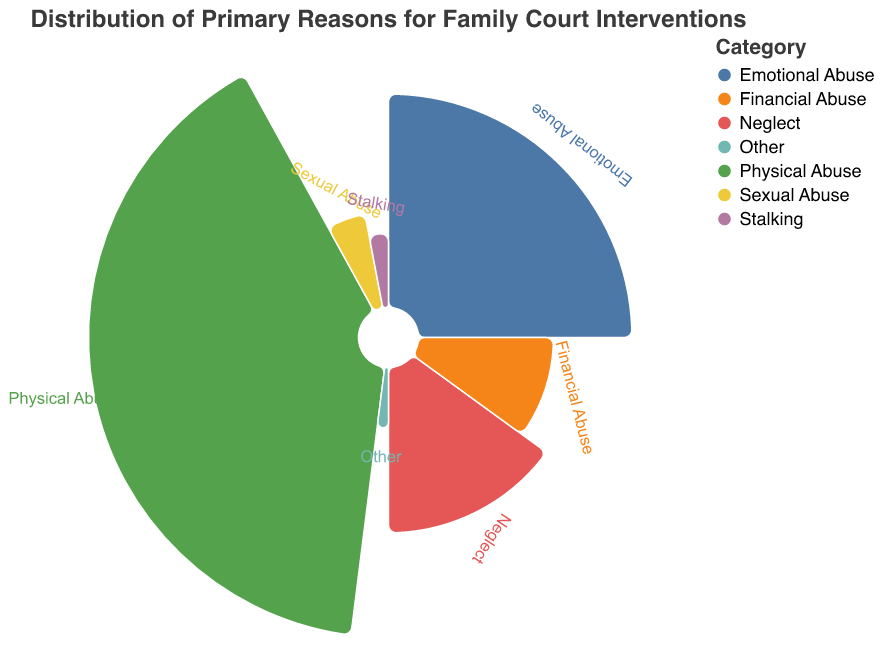What is the primary reason for family court interventions according to the polar chart? The polar chart shows different categories of family court interventions, with "Physical Abuse" having the largest wedge and thus the highest number, which is 40.
Answer: Physical Abuse How many family court interventions are due to Emotional Abuse? In the polar chart, the segment labeled "Emotional Abuse" shows a value of 25, indicating its share.
Answer: 25 What is the combined total of interventions for Neglect and Financial Abuse? The chart shows that Neglect has 15 interventions and Financial Abuse has 10. Adding these together gives 15 + 10 = 25.
Answer: 25 Which category has the least number of family court interventions? The smallest wedge in the polar chart is labeled "Other," showing a count of 2 interventions.
Answer: Other How does the number of interventions for Sexual Abuse compare to those for Stalking? The polar chart indicates that Sexual Abuse has 5 interventions and Stalking has 3 interventions. Comparing these shows that Sexual Abuse has more interventions than Stalking.
Answer: Sexual Abuse has more What percentage of the total interventions are due to Physical Abuse? Summing the total number of interventions in the chart results in 100 (40 + 25 + 15 + 10 + 5 + 3 + 2). The percentage for Physical Abuse is (40 / 100) * 100% = 40%.
Answer: 40% What is the median number of interventions across all categories? Arranging the values in numerical order: 2, 3, 5, 10, 15, 25, 40. The middle value, 10, is the median.
Answer: 10 How many more interventions are attributed to Emotional Abuse compared to Sexual Abuse? Emotional Abuse has 25 interventions versus 5 for Sexual Abuse. The difference is 25 - 5 = 20.
Answer: 20 Which two categories together account for exactly half of all interventions? The total interventions are 100. "Physical Abuse" and "Emotional Abuse" together have 40 + 25 = 65, which is more, so we try pairs of smaller values. Upon checking "Neglect" and "Financial Abuse," the pair sums to 15 + 10 = 25, which is 1/4th. Finally, for a half, "Neglect" and "Physical Abuse" exactly add up to 40 + 10 = 50.
Answer: Physical Abuse and Neglect What does the radius of the arcs in the polar chart represent? The radius of the arcs represents the magnitude of family court interventions for each category, with larger radii indicating higher intervention counts.
Answer: Magnitude of interventions 